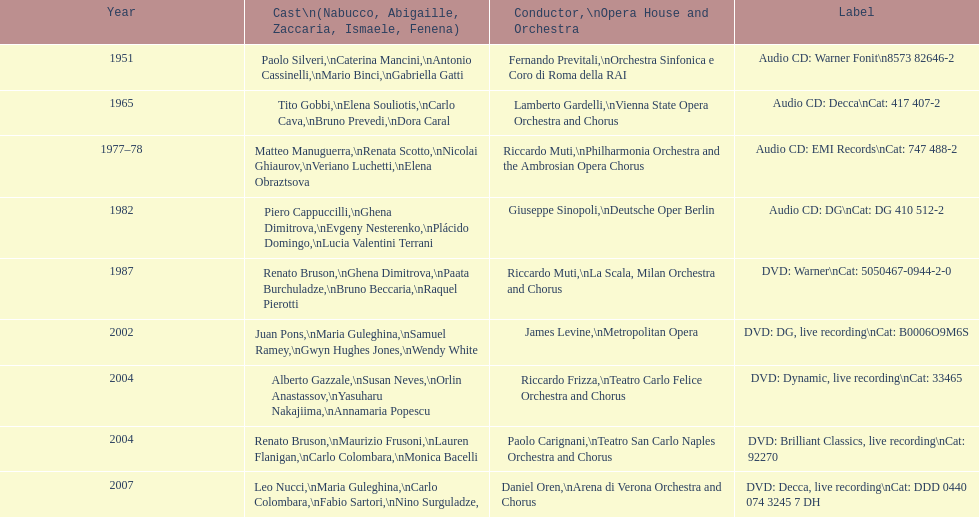What is the total number of nabucco recordings produced? 9. 